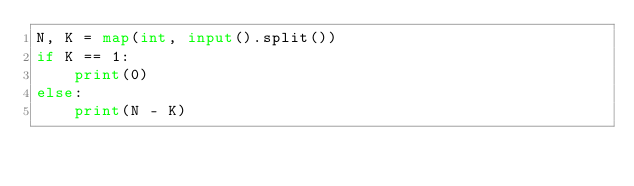Convert code to text. <code><loc_0><loc_0><loc_500><loc_500><_Python_>N, K = map(int, input().split())
if K == 1:
    print(0)
else:
    print(N - K)</code> 